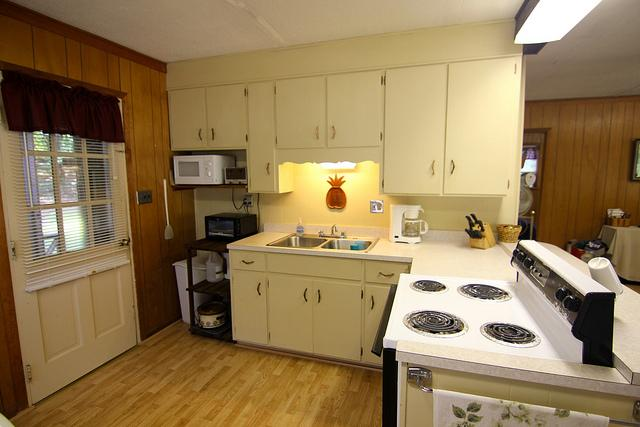How is the kitchen counter by the stove illuminated? overhead lamp 